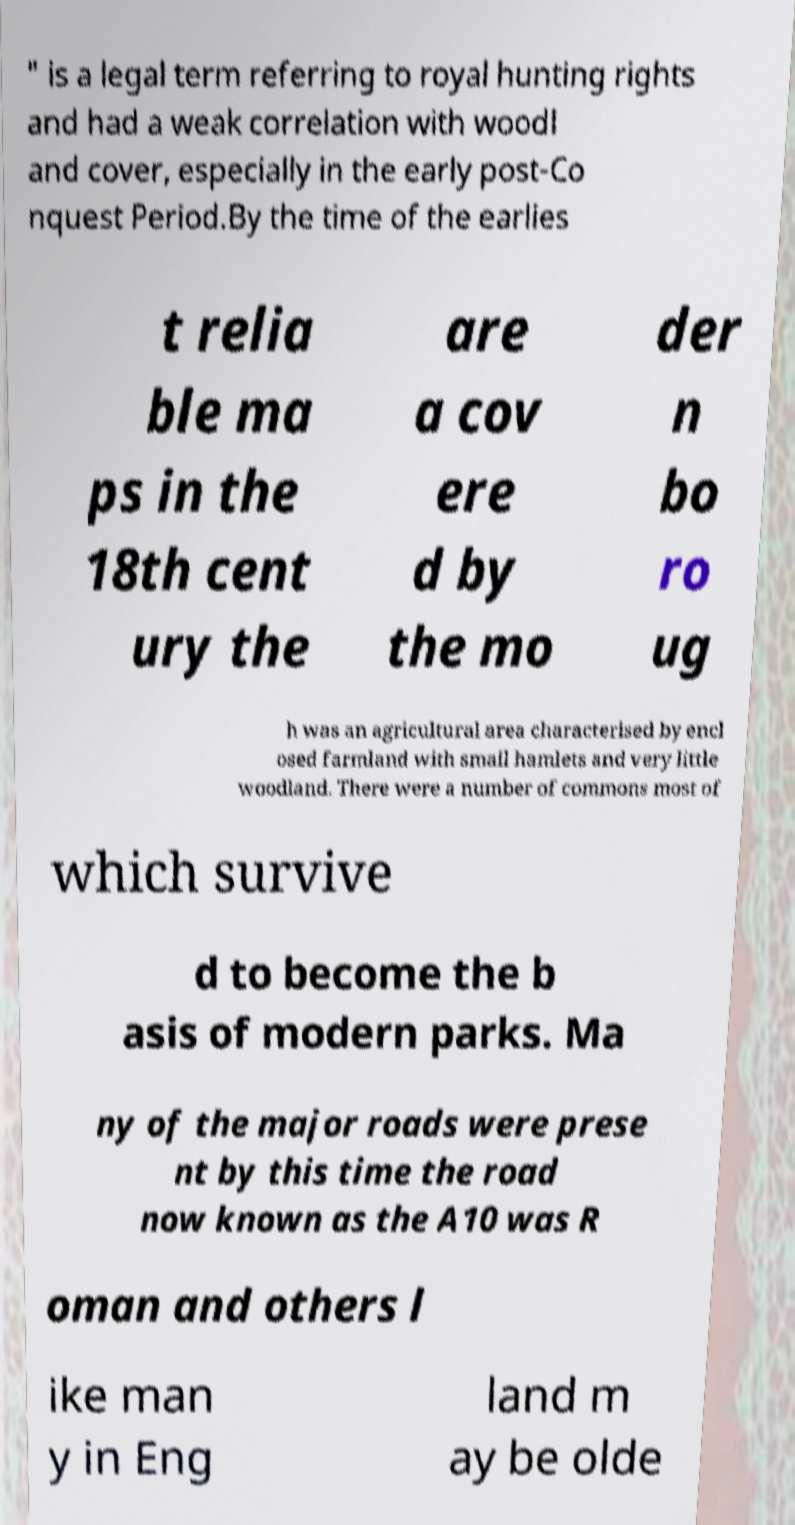For documentation purposes, I need the text within this image transcribed. Could you provide that? " is a legal term referring to royal hunting rights and had a weak correlation with woodl and cover, especially in the early post-Co nquest Period.By the time of the earlies t relia ble ma ps in the 18th cent ury the are a cov ere d by the mo der n bo ro ug h was an agricultural area characterised by encl osed farmland with small hamlets and very little woodland. There were a number of commons most of which survive d to become the b asis of modern parks. Ma ny of the major roads were prese nt by this time the road now known as the A10 was R oman and others l ike man y in Eng land m ay be olde 